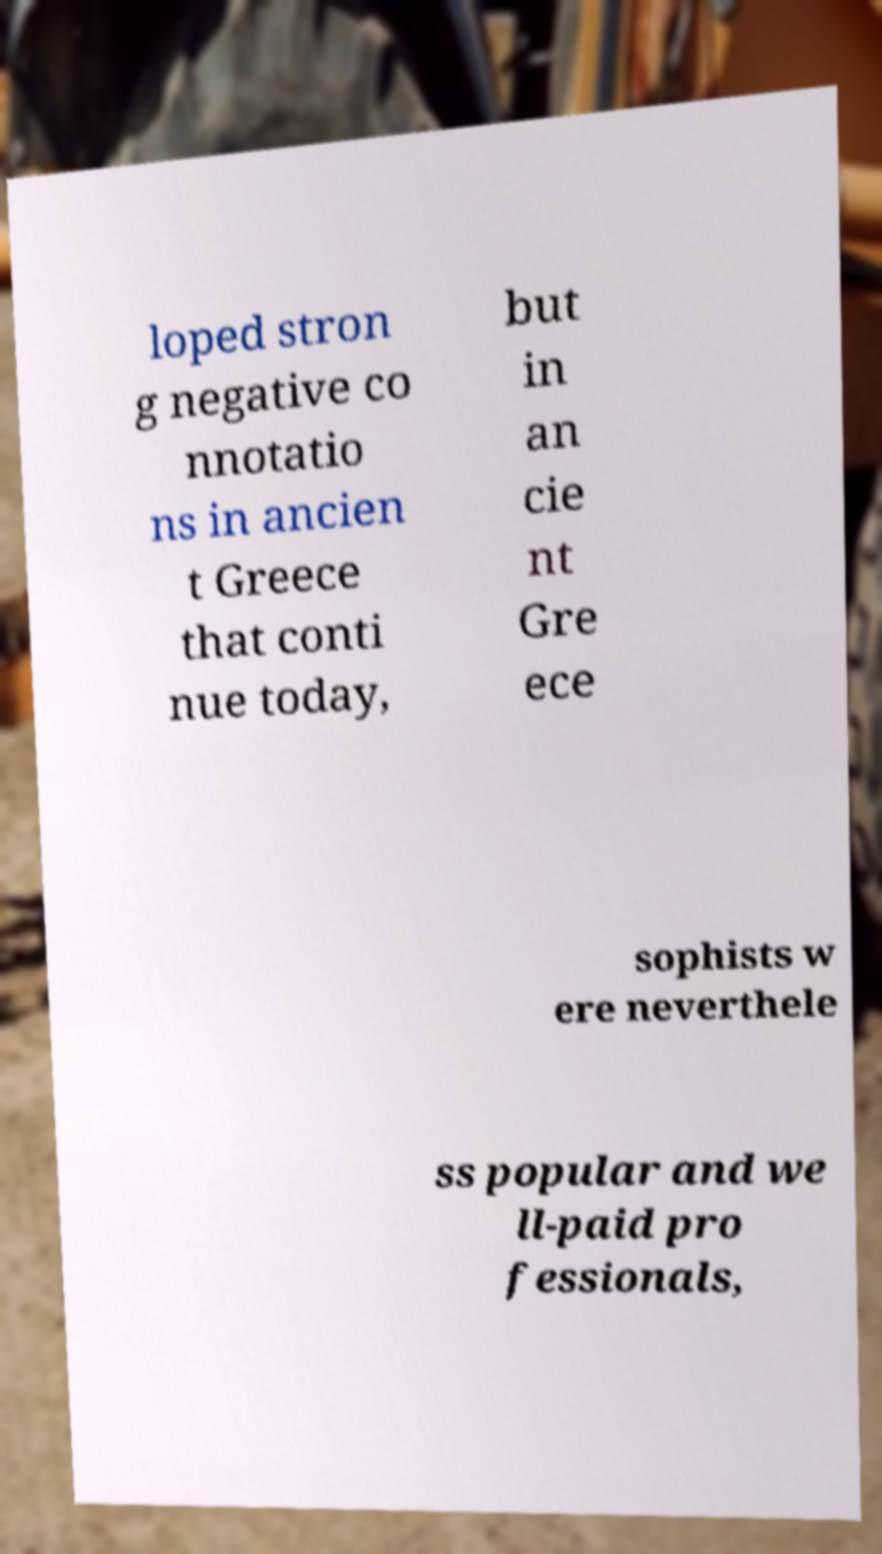For documentation purposes, I need the text within this image transcribed. Could you provide that? loped stron g negative co nnotatio ns in ancien t Greece that conti nue today, but in an cie nt Gre ece sophists w ere neverthele ss popular and we ll-paid pro fessionals, 